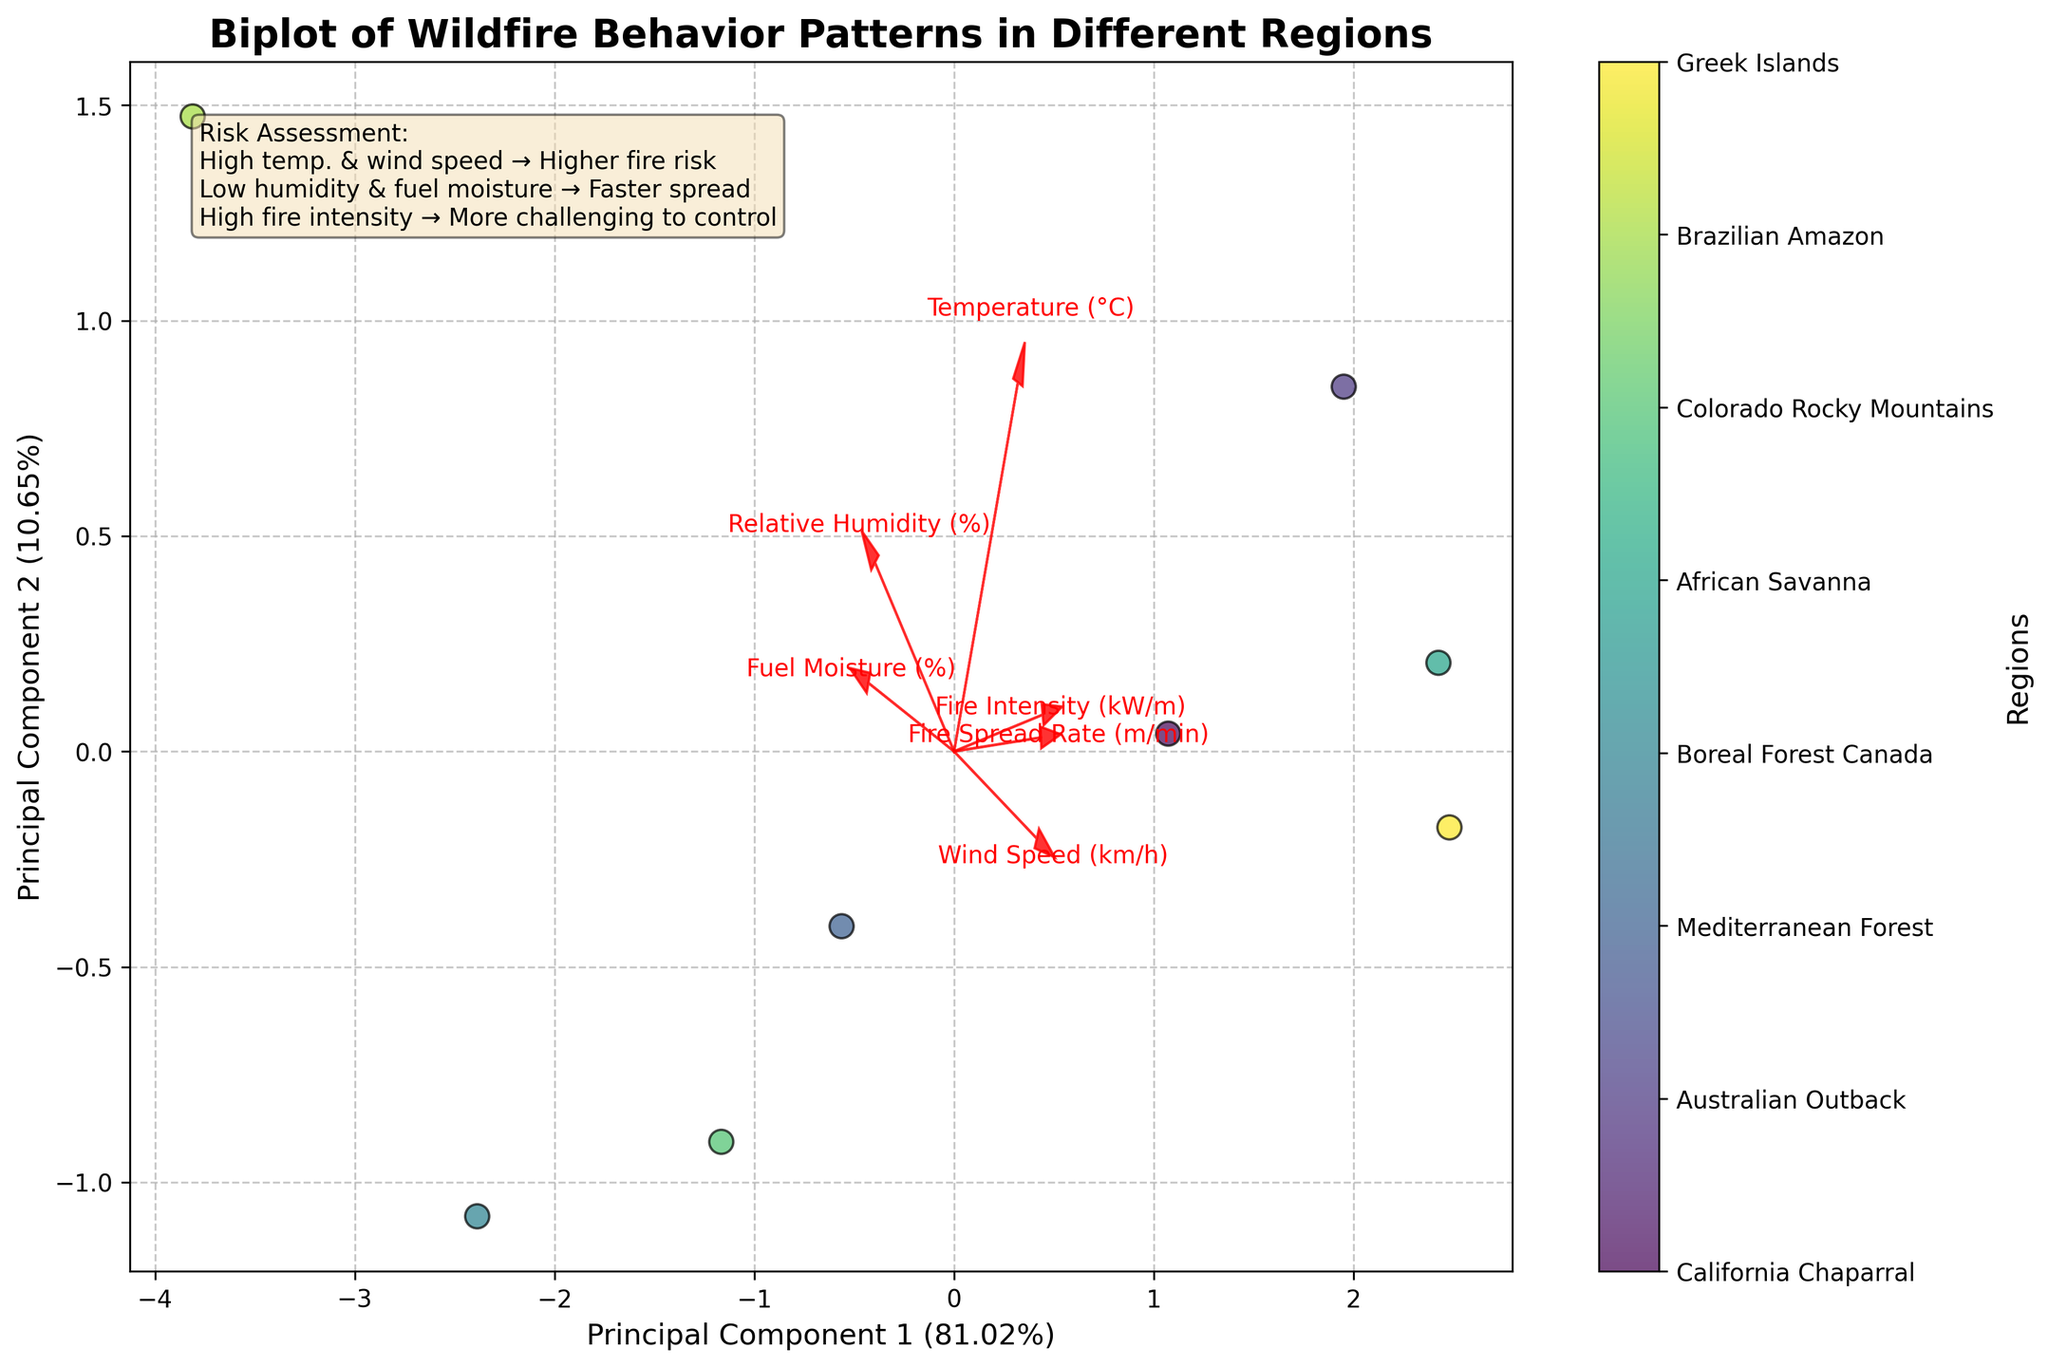How many regions are represented in the biplot? The color bar legend shows the number of different regions, each represented by a distinct color.
Answer: 8 What does the first principal component explain? The label on the x-axis indicates the percentage of explained variance by the first principal component.
Answer: 54% Which parameter seems to have the most significant impact on the fire spread rate? Fire spread rate is affected by multiple parameters as shown by the orientation of the arrows. Temperature (°C) and Wind Speed (km/h) arrows point in a similar direction, suggesting a correlation with fire spread rate.
Answer: Temperature (°C) and Wind Speed (km/h) Which region is associated with the highest fire intensity? The color bar legend indicates specific regions, and their positioning in the biplot helps understand their relative fire intensity. The region projected farthest in the component correlating to high fire intensity is Greek Islands.
Answer: Greek Islands What is the relationship between fuel moisture and relative humidity? The arrows in the biplot show the direction and length representing the correlation of those features. Observing their orientation, fuel moisture and relative humidity arrows point in somewhat similar directions, indicating a positive relationship.
Answer: Positive relationship How do the vectors for wind speed and fire intensity relate to each other? The biplot shows arrows for wind speed and fire intensity pointing in similar directions, indicating a positive correlation between these variables.
Answer: Positive correlation Which region is likely to have the highest risk of wildfire spread according to the biplot? The text box on the plot provides general rules about how high temperature and wind speed increase fire spread risk, combined with the position of regions relative to these arrows. The region Greek Islands is positioned in the direction indicating high fire spread rate.
Answer: Greek Islands Why is Principal Component 2 important? The y-axis label shows that it explains a portion of the variance in the data, and the arrows pointing predominantly in the vertical direction indicate which features contribute to this principal component.
Answer: It explains 23% of the variance What characteristic correlates most strongly with Principal Component 1? Observing the biplot, check which variables' arrows align most closely with the x-axis. Temperature (°C) lies close to the x-axis indicating a strong correlation with Principal Component 1.
Answer: Temperature (°C) Which region is characterized by relatively high relative humidity? The biplot can be used to visually estimate the regions that project onto the direction of the relative humidity arrow. The Brazilian Amazon is positioned in this direction.
Answer: Brazilian Amazon 